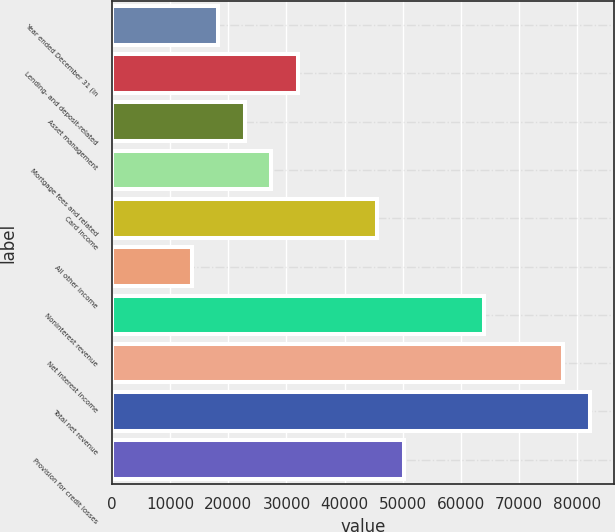<chart> <loc_0><loc_0><loc_500><loc_500><bar_chart><fcel>Year ended December 31 (in<fcel>Lending- and deposit-related<fcel>Asset management<fcel>Mortgage fees and related<fcel>Card income<fcel>All other income<fcel>Noninterest revenue<fcel>Net interest income<fcel>Total net revenue<fcel>Provision for credit losses<nl><fcel>18256.6<fcel>31937.8<fcel>22817<fcel>27377.4<fcel>45619<fcel>13696.2<fcel>63860.6<fcel>77541.8<fcel>82102.2<fcel>50179.4<nl></chart> 